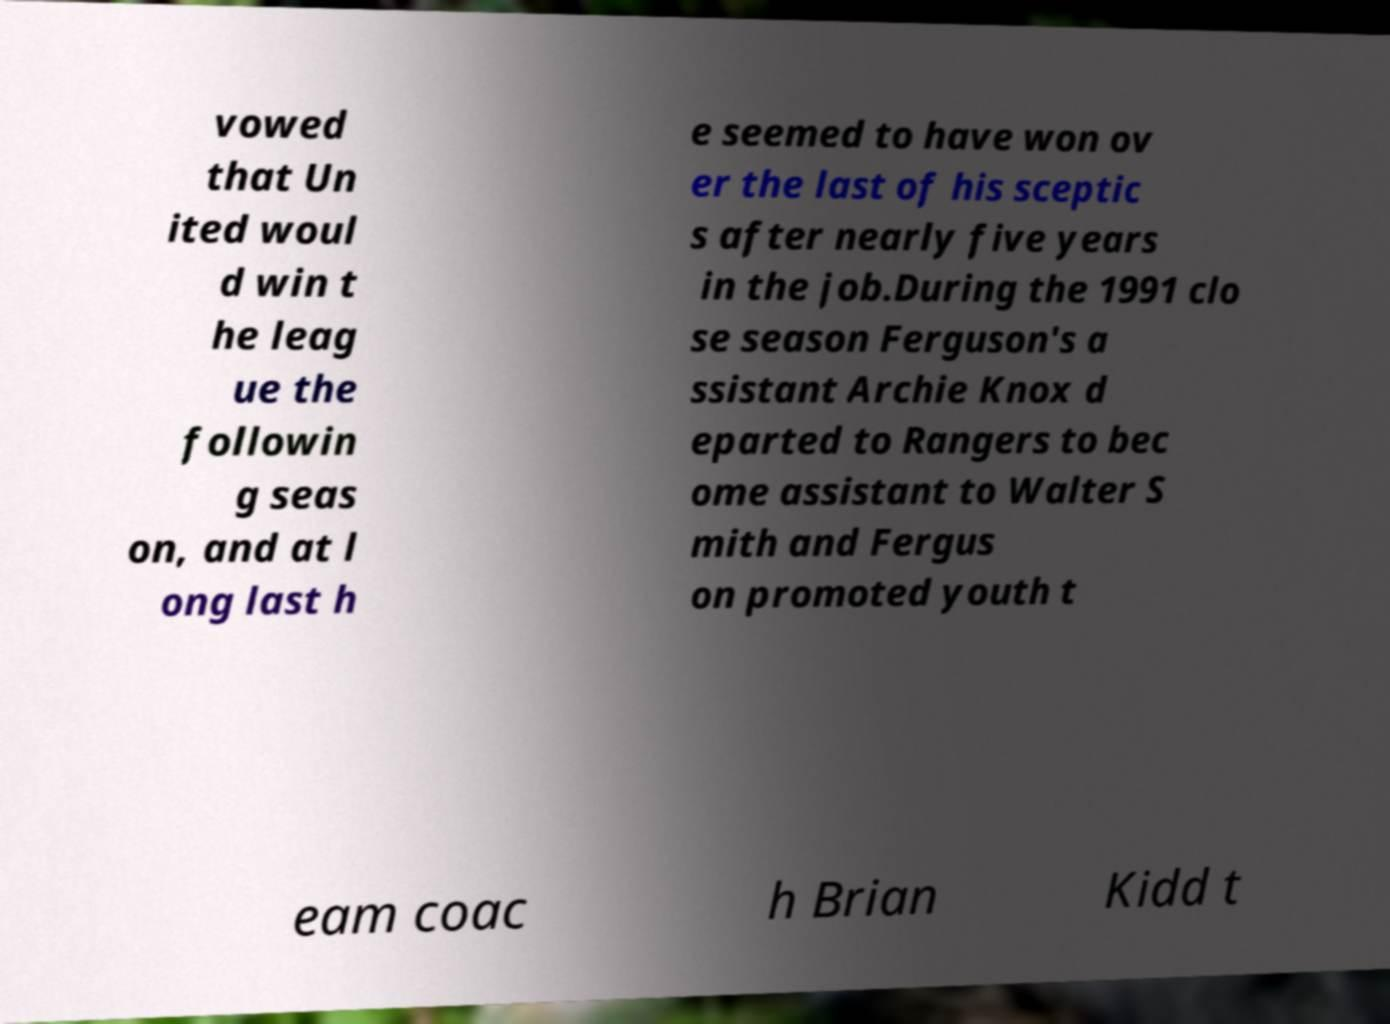Can you accurately transcribe the text from the provided image for me? vowed that Un ited woul d win t he leag ue the followin g seas on, and at l ong last h e seemed to have won ov er the last of his sceptic s after nearly five years in the job.During the 1991 clo se season Ferguson's a ssistant Archie Knox d eparted to Rangers to bec ome assistant to Walter S mith and Fergus on promoted youth t eam coac h Brian Kidd t 